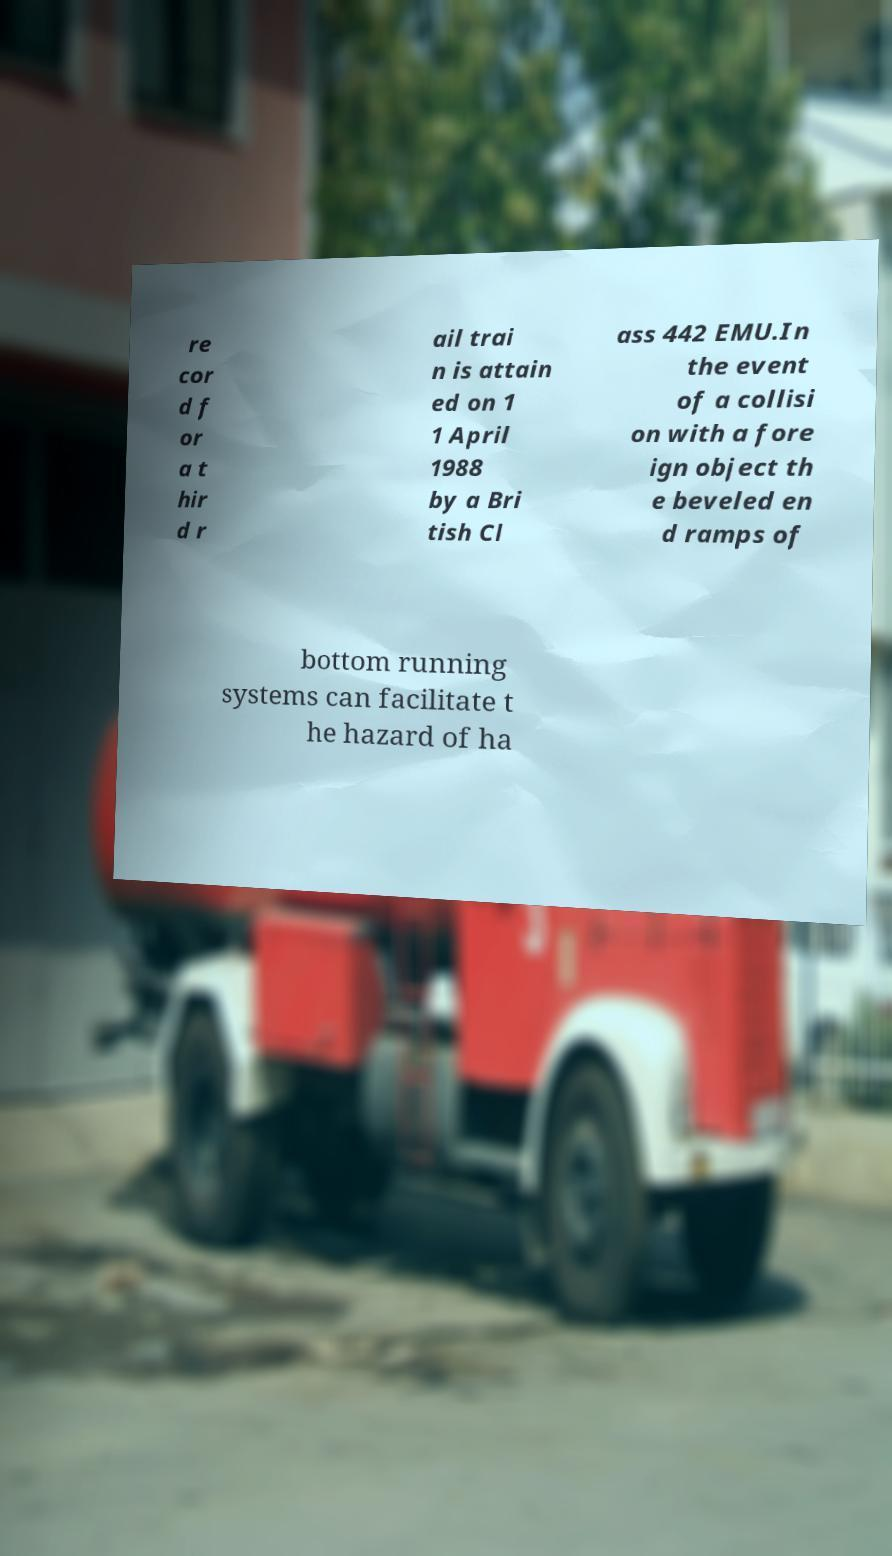There's text embedded in this image that I need extracted. Can you transcribe it verbatim? re cor d f or a t hir d r ail trai n is attain ed on 1 1 April 1988 by a Bri tish Cl ass 442 EMU.In the event of a collisi on with a fore ign object th e beveled en d ramps of bottom running systems can facilitate t he hazard of ha 